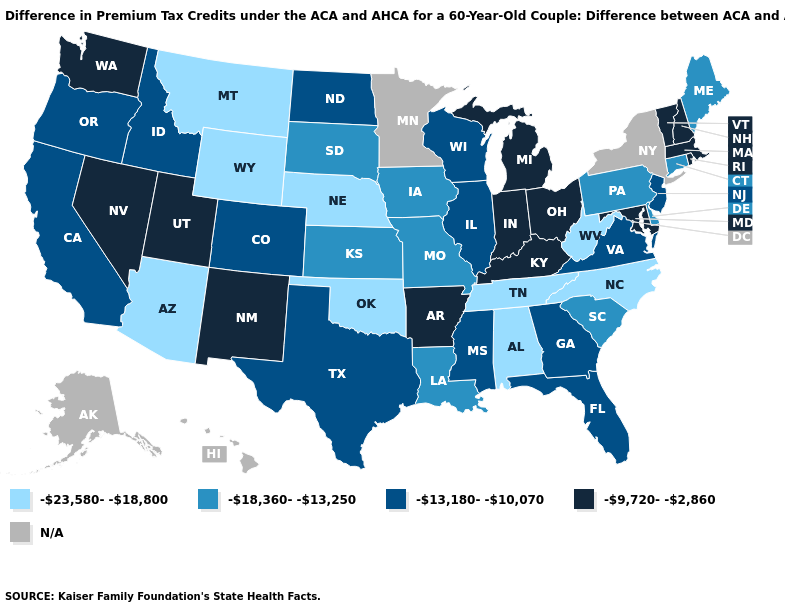What is the value of Vermont?
Quick response, please. -9,720--2,860. Name the states that have a value in the range -18,360--13,250?
Give a very brief answer. Connecticut, Delaware, Iowa, Kansas, Louisiana, Maine, Missouri, Pennsylvania, South Carolina, South Dakota. Which states have the lowest value in the USA?
Keep it brief. Alabama, Arizona, Montana, Nebraska, North Carolina, Oklahoma, Tennessee, West Virginia, Wyoming. What is the lowest value in states that border Nevada?
Be succinct. -23,580--18,800. What is the value of Arkansas?
Write a very short answer. -9,720--2,860. What is the value of Maryland?
Answer briefly. -9,720--2,860. Does the map have missing data?
Be succinct. Yes. What is the highest value in states that border Michigan?
Keep it brief. -9,720--2,860. Which states have the lowest value in the West?
Quick response, please. Arizona, Montana, Wyoming. What is the value of Pennsylvania?
Give a very brief answer. -18,360--13,250. What is the value of Ohio?
Quick response, please. -9,720--2,860. Name the states that have a value in the range N/A?
Give a very brief answer. Alaska, Hawaii, Minnesota, New York. Among the states that border Iowa , which have the lowest value?
Write a very short answer. Nebraska. 